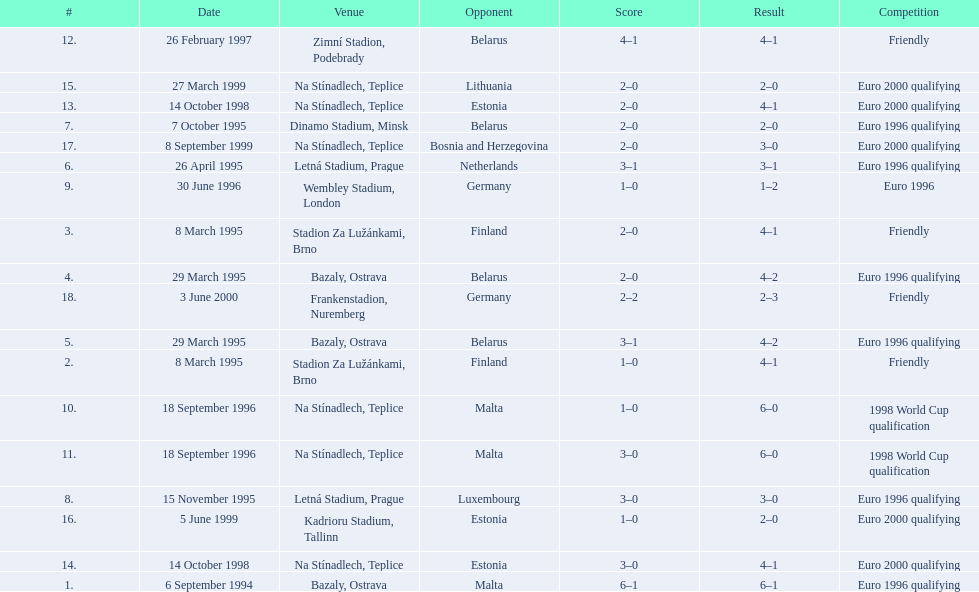Bazaly, ostrava was used on 6 september 1004, but what venue was used on 18 september 1996? Na Stínadlech, Teplice. 